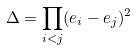<formula> <loc_0><loc_0><loc_500><loc_500>\Delta = \prod _ { i < j } ( e _ { i } - e _ { j } ) ^ { 2 }</formula> 